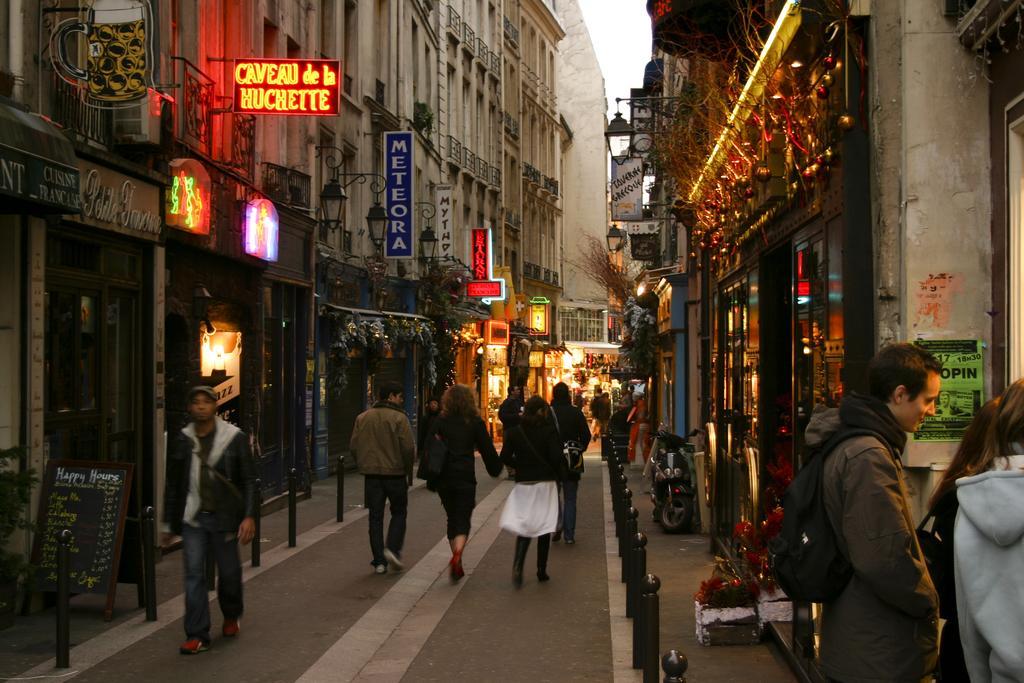Describe this image in one or two sentences. in this image we can see a group of people standing on the ground. On the right side of the image we can see a person wearing bag, a motorcycle parked on the road. In the background, we can see group of sign boards placed on the buildings, groups of lights, poles. A board placed on the ground and the sky. 